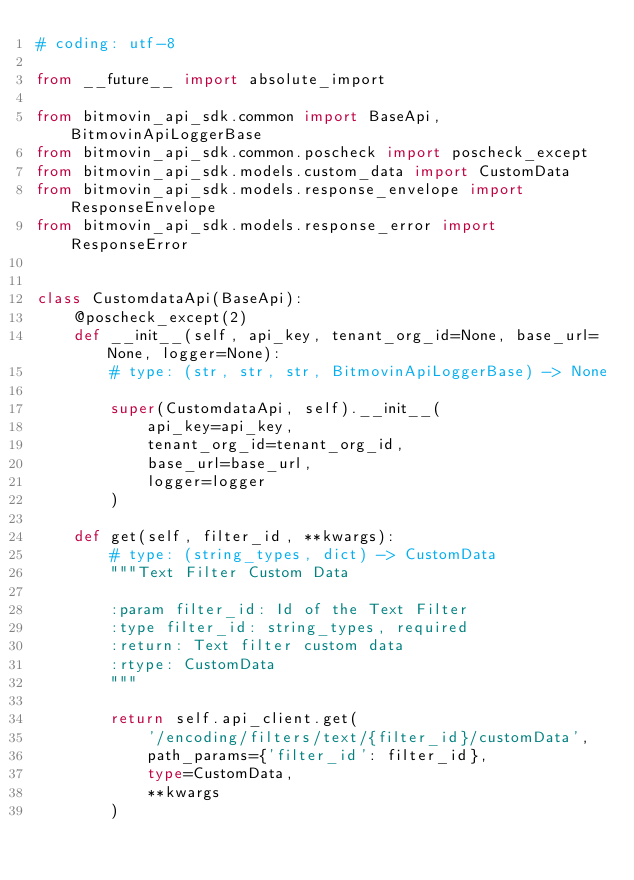<code> <loc_0><loc_0><loc_500><loc_500><_Python_># coding: utf-8

from __future__ import absolute_import

from bitmovin_api_sdk.common import BaseApi, BitmovinApiLoggerBase
from bitmovin_api_sdk.common.poscheck import poscheck_except
from bitmovin_api_sdk.models.custom_data import CustomData
from bitmovin_api_sdk.models.response_envelope import ResponseEnvelope
from bitmovin_api_sdk.models.response_error import ResponseError


class CustomdataApi(BaseApi):
    @poscheck_except(2)
    def __init__(self, api_key, tenant_org_id=None, base_url=None, logger=None):
        # type: (str, str, str, BitmovinApiLoggerBase) -> None

        super(CustomdataApi, self).__init__(
            api_key=api_key,
            tenant_org_id=tenant_org_id,
            base_url=base_url,
            logger=logger
        )

    def get(self, filter_id, **kwargs):
        # type: (string_types, dict) -> CustomData
        """Text Filter Custom Data

        :param filter_id: Id of the Text Filter
        :type filter_id: string_types, required
        :return: Text filter custom data
        :rtype: CustomData
        """

        return self.api_client.get(
            '/encoding/filters/text/{filter_id}/customData',
            path_params={'filter_id': filter_id},
            type=CustomData,
            **kwargs
        )
</code> 